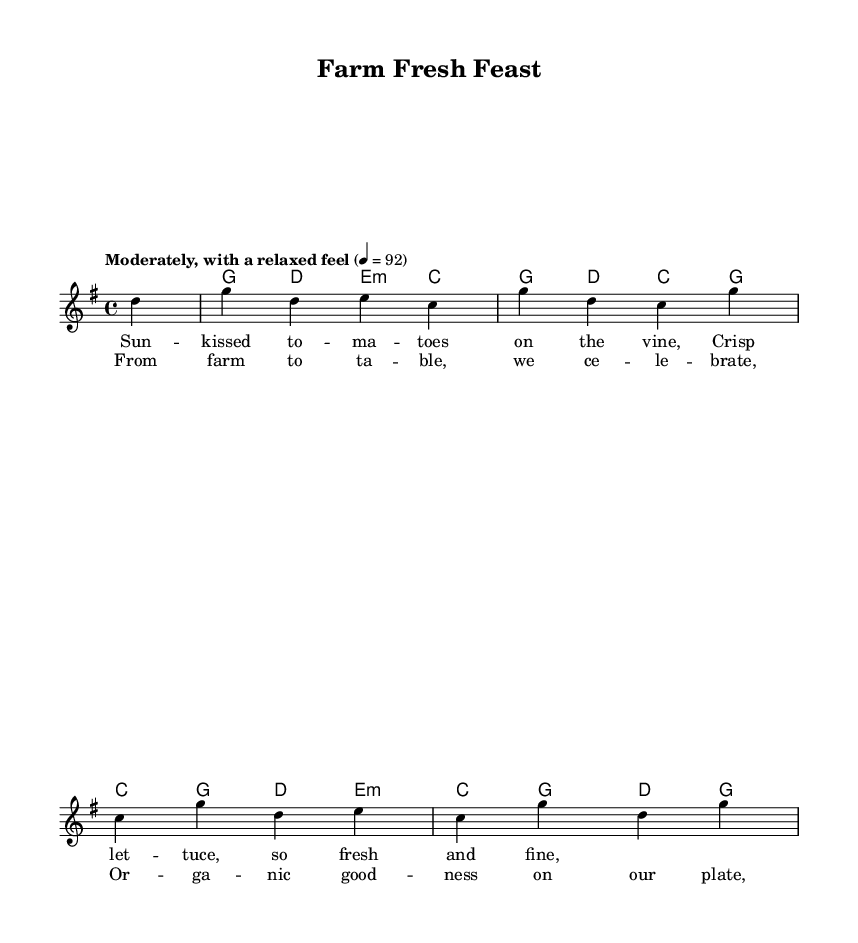What is the key signature of this music? The key signature indicates that there is one sharp, which corresponds to G major.
Answer: G major What is the time signature of this music? The time signature at the beginning shows there are four beats in each measure, indicated as 4/4.
Answer: 4/4 What is the tempo marking of this piece? The tempo marking states "Moderately, with a relaxed feel," which indicates the overall character of the performance speed.
Answer: Moderately How many measures are there in the melody? Counting the measures in the melody section reveals that there are five distinct measures.
Answer: Five What do the lyrics celebrate in this song? The lyrics focus on celebrating organic produce and farm-fresh food, highlighted in the chorus.
Answer: Organic goodness Which musical element appears at the beginning of the score? The chord names are indicated at the beginning of the score, as shown in the ChordNames section.
Answer: Chord names What theme is emphasized in the title of the piece? The title "Farm Fresh Feast" emphasizes the theme of fresh, farm-sourced food and the celebration of healthy eating.
Answer: Fresh food 